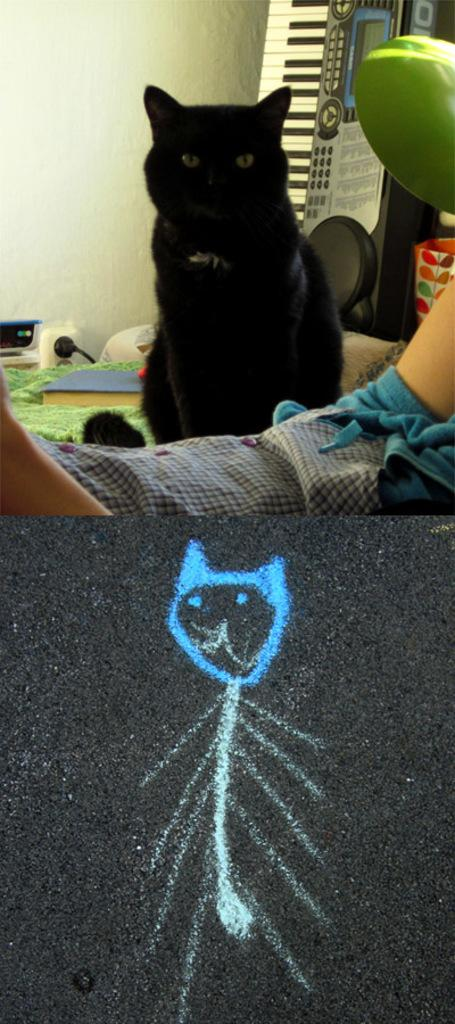What animal can be seen in the image? There is a cat in the image. Where is the cat located in relation to other objects in the image? The cat is in front of a wall. What musical instrument is visible in the image? There is a piano in the top right of the image. What type of artwork is present at the bottom of the image? There is an art piece at the bottom of the image. What type of pest is the cat attempting to eliminate in the image? There is no indication in the image that the cat is attempting to eliminate any pests. 